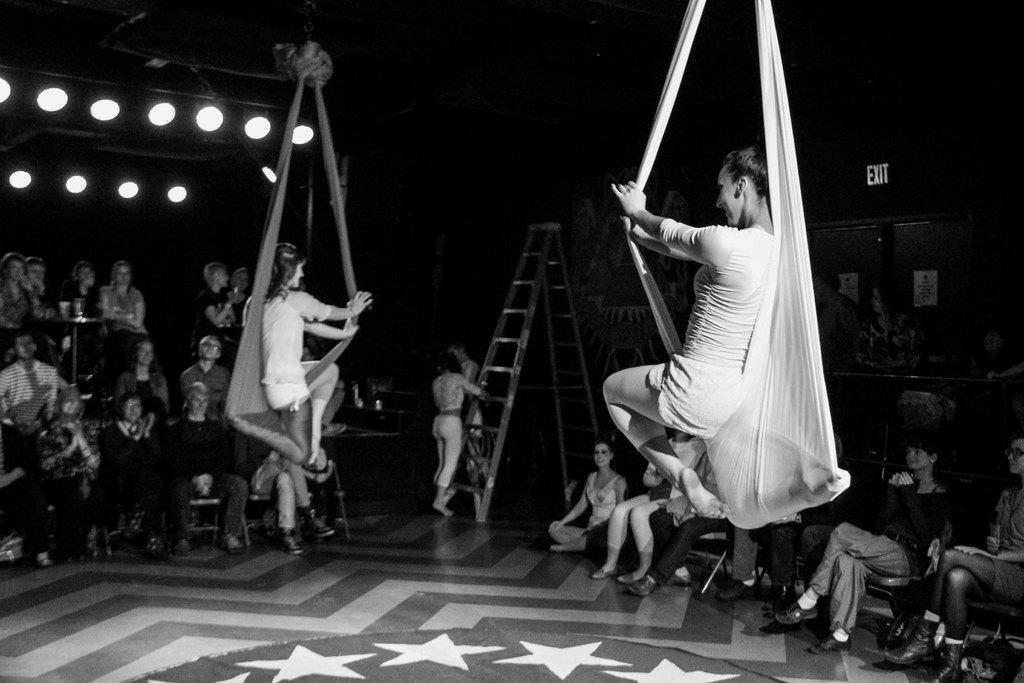Describe this image in one or two sentences. In this picture we can see two are hanging with the cloth, beside we can see so many people are sitting and watching. 